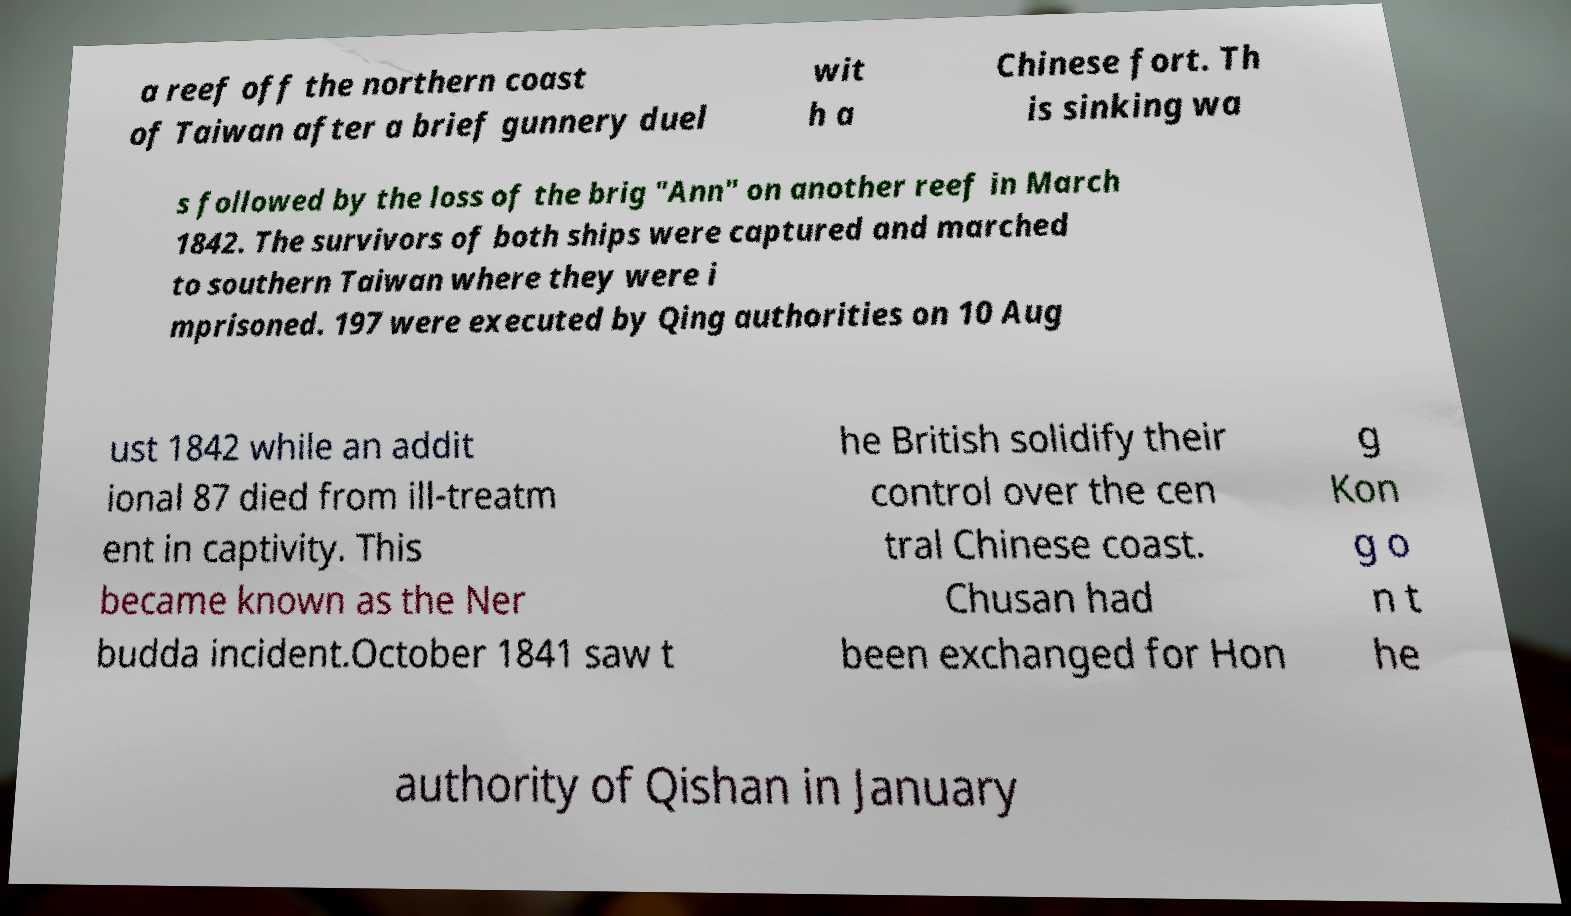Can you read and provide the text displayed in the image?This photo seems to have some interesting text. Can you extract and type it out for me? a reef off the northern coast of Taiwan after a brief gunnery duel wit h a Chinese fort. Th is sinking wa s followed by the loss of the brig "Ann" on another reef in March 1842. The survivors of both ships were captured and marched to southern Taiwan where they were i mprisoned. 197 were executed by Qing authorities on 10 Aug ust 1842 while an addit ional 87 died from ill-treatm ent in captivity. This became known as the Ner budda incident.October 1841 saw t he British solidify their control over the cen tral Chinese coast. Chusan had been exchanged for Hon g Kon g o n t he authority of Qishan in January 